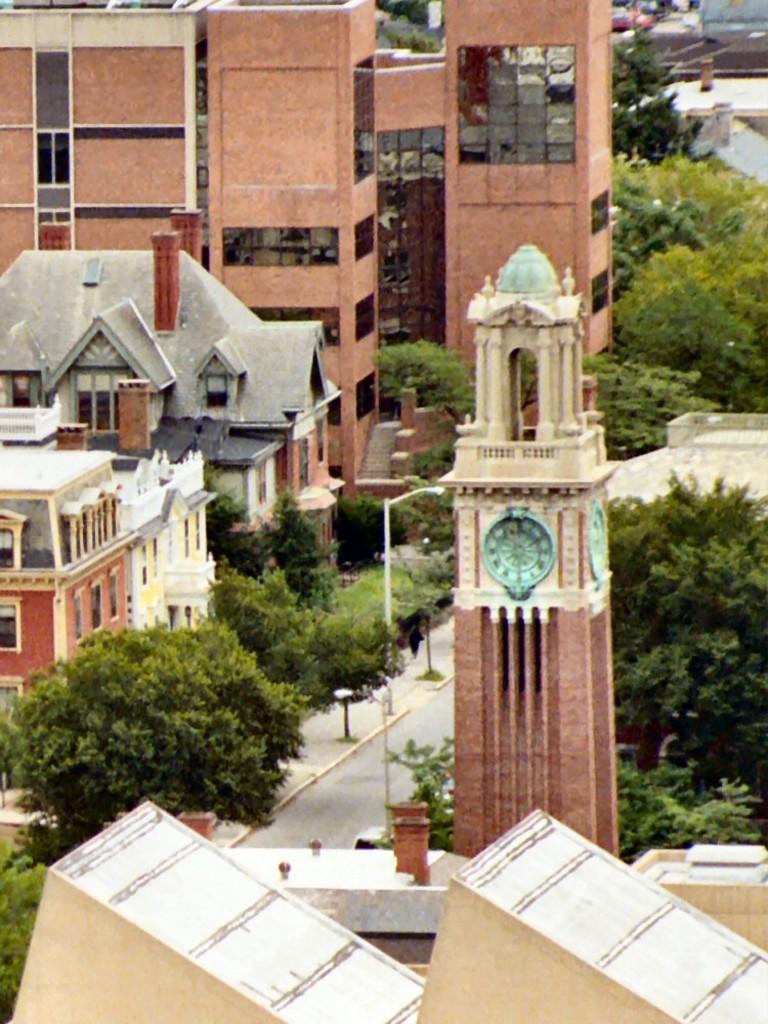Can you describe this image briefly? This picture might be taken from outside of the city. In this image, on the right side and left side, we can see two pillars. In the middle of the image, we can see a tower, street light. On the right side, we can see some trees. On the left side, we can see some trees, plants, glass windows. In the background, we can also see some trees, vehicles. At the bottom, we can see a road and a footpath. 